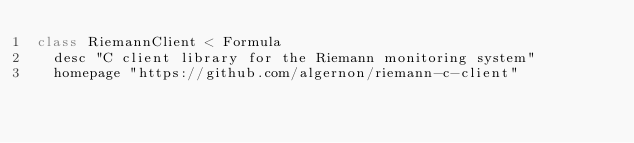<code> <loc_0><loc_0><loc_500><loc_500><_Ruby_>class RiemannClient < Formula
  desc "C client library for the Riemann monitoring system"
  homepage "https://github.com/algernon/riemann-c-client"</code> 